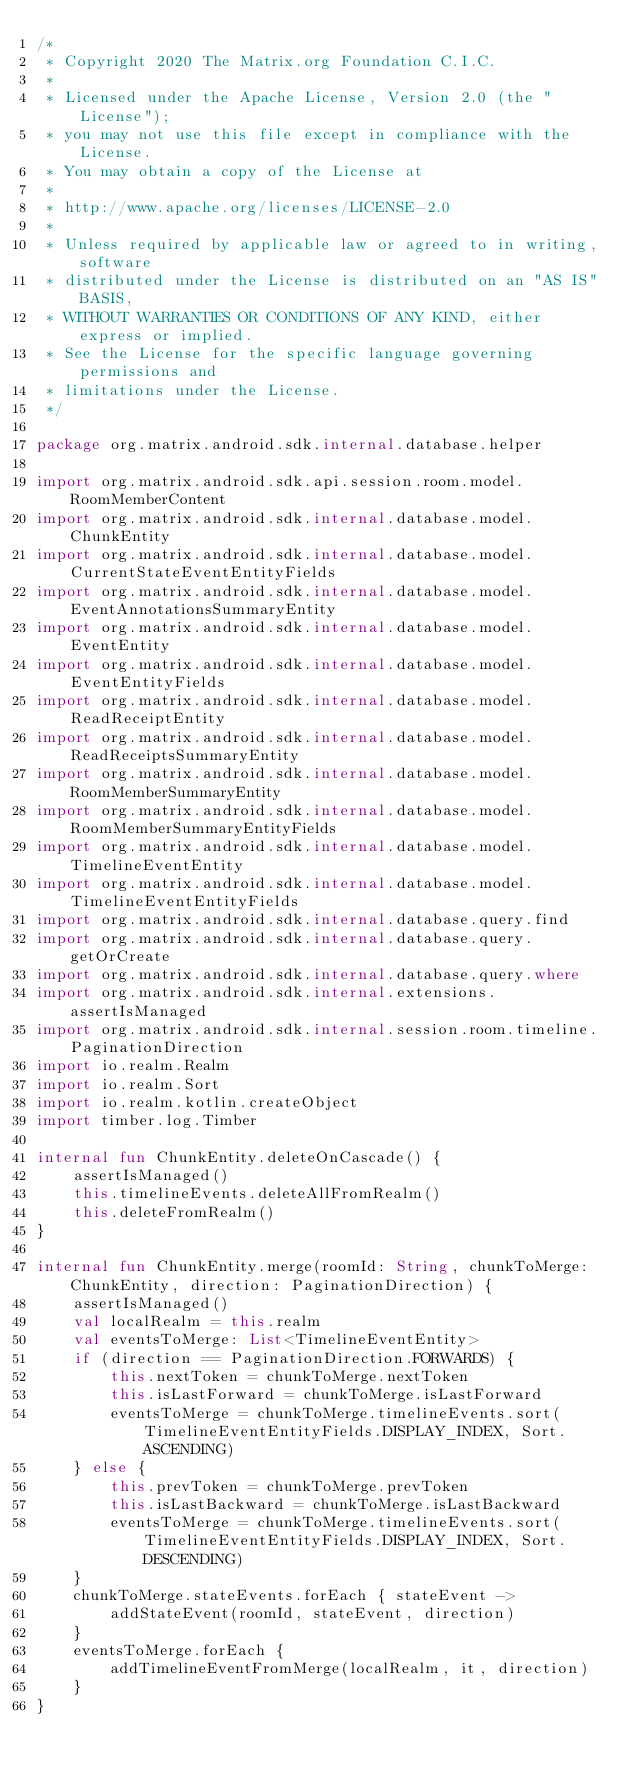Convert code to text. <code><loc_0><loc_0><loc_500><loc_500><_Kotlin_>/*
 * Copyright 2020 The Matrix.org Foundation C.I.C.
 *
 * Licensed under the Apache License, Version 2.0 (the "License");
 * you may not use this file except in compliance with the License.
 * You may obtain a copy of the License at
 *
 * http://www.apache.org/licenses/LICENSE-2.0
 *
 * Unless required by applicable law or agreed to in writing, software
 * distributed under the License is distributed on an "AS IS" BASIS,
 * WITHOUT WARRANTIES OR CONDITIONS OF ANY KIND, either express or implied.
 * See the License for the specific language governing permissions and
 * limitations under the License.
 */

package org.matrix.android.sdk.internal.database.helper

import org.matrix.android.sdk.api.session.room.model.RoomMemberContent
import org.matrix.android.sdk.internal.database.model.ChunkEntity
import org.matrix.android.sdk.internal.database.model.CurrentStateEventEntityFields
import org.matrix.android.sdk.internal.database.model.EventAnnotationsSummaryEntity
import org.matrix.android.sdk.internal.database.model.EventEntity
import org.matrix.android.sdk.internal.database.model.EventEntityFields
import org.matrix.android.sdk.internal.database.model.ReadReceiptEntity
import org.matrix.android.sdk.internal.database.model.ReadReceiptsSummaryEntity
import org.matrix.android.sdk.internal.database.model.RoomMemberSummaryEntity
import org.matrix.android.sdk.internal.database.model.RoomMemberSummaryEntityFields
import org.matrix.android.sdk.internal.database.model.TimelineEventEntity
import org.matrix.android.sdk.internal.database.model.TimelineEventEntityFields
import org.matrix.android.sdk.internal.database.query.find
import org.matrix.android.sdk.internal.database.query.getOrCreate
import org.matrix.android.sdk.internal.database.query.where
import org.matrix.android.sdk.internal.extensions.assertIsManaged
import org.matrix.android.sdk.internal.session.room.timeline.PaginationDirection
import io.realm.Realm
import io.realm.Sort
import io.realm.kotlin.createObject
import timber.log.Timber

internal fun ChunkEntity.deleteOnCascade() {
    assertIsManaged()
    this.timelineEvents.deleteAllFromRealm()
    this.deleteFromRealm()
}

internal fun ChunkEntity.merge(roomId: String, chunkToMerge: ChunkEntity, direction: PaginationDirection) {
    assertIsManaged()
    val localRealm = this.realm
    val eventsToMerge: List<TimelineEventEntity>
    if (direction == PaginationDirection.FORWARDS) {
        this.nextToken = chunkToMerge.nextToken
        this.isLastForward = chunkToMerge.isLastForward
        eventsToMerge = chunkToMerge.timelineEvents.sort(TimelineEventEntityFields.DISPLAY_INDEX, Sort.ASCENDING)
    } else {
        this.prevToken = chunkToMerge.prevToken
        this.isLastBackward = chunkToMerge.isLastBackward
        eventsToMerge = chunkToMerge.timelineEvents.sort(TimelineEventEntityFields.DISPLAY_INDEX, Sort.DESCENDING)
    }
    chunkToMerge.stateEvents.forEach { stateEvent ->
        addStateEvent(roomId, stateEvent, direction)
    }
    eventsToMerge.forEach {
        addTimelineEventFromMerge(localRealm, it, direction)
    }
}
</code> 